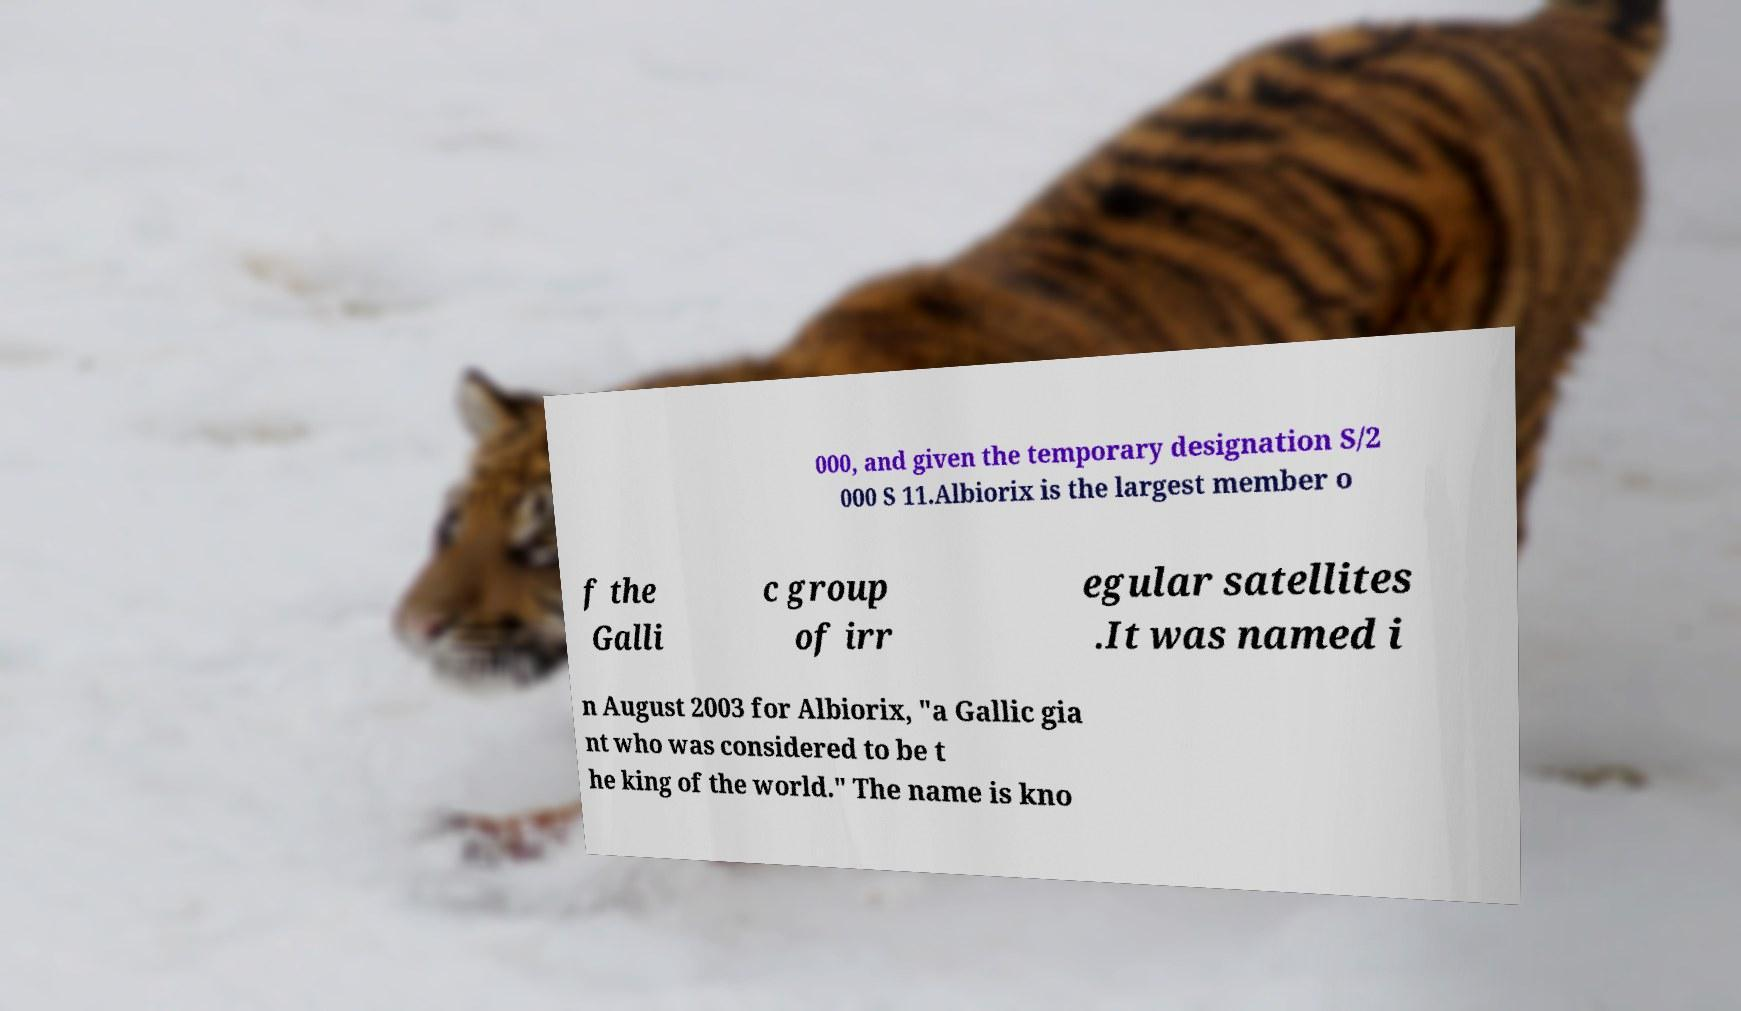Please read and relay the text visible in this image. What does it say? 000, and given the temporary designation S/2 000 S 11.Albiorix is the largest member o f the Galli c group of irr egular satellites .It was named i n August 2003 for Albiorix, "a Gallic gia nt who was considered to be t he king of the world." The name is kno 